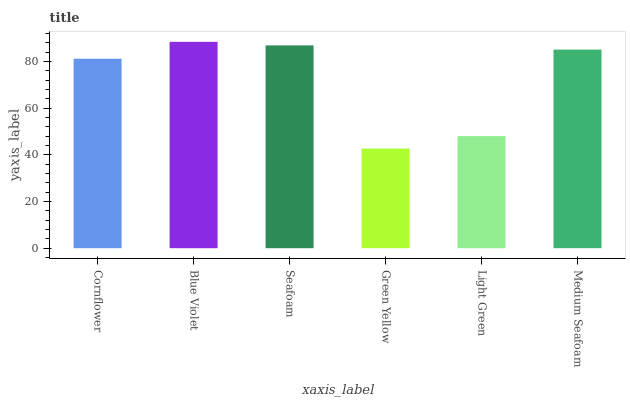Is Green Yellow the minimum?
Answer yes or no. Yes. Is Blue Violet the maximum?
Answer yes or no. Yes. Is Seafoam the minimum?
Answer yes or no. No. Is Seafoam the maximum?
Answer yes or no. No. Is Blue Violet greater than Seafoam?
Answer yes or no. Yes. Is Seafoam less than Blue Violet?
Answer yes or no. Yes. Is Seafoam greater than Blue Violet?
Answer yes or no. No. Is Blue Violet less than Seafoam?
Answer yes or no. No. Is Medium Seafoam the high median?
Answer yes or no. Yes. Is Cornflower the low median?
Answer yes or no. Yes. Is Green Yellow the high median?
Answer yes or no. No. Is Green Yellow the low median?
Answer yes or no. No. 